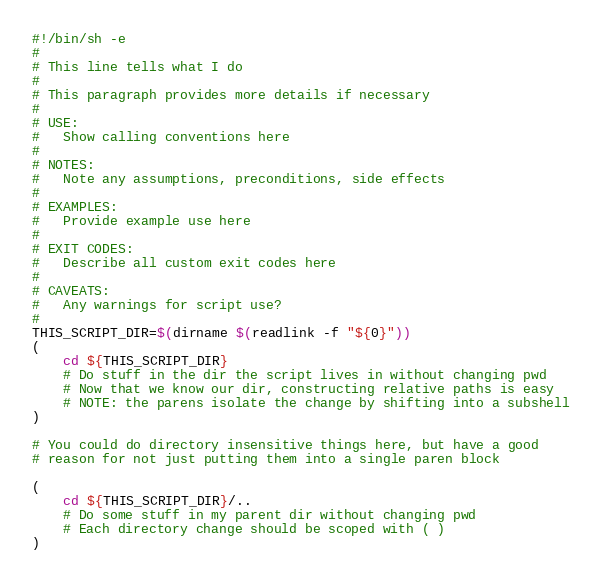Convert code to text. <code><loc_0><loc_0><loc_500><loc_500><_Bash_>#!/bin/sh -e
#
# This line tells what I do
#
# This paragraph provides more details if necessary
#
# USE:
#   Show calling conventions here
#
# NOTES:
#   Note any assumptions, preconditions, side effects
#
# EXAMPLES:
#   Provide example use here
#
# EXIT CODES:
#   Describe all custom exit codes here
#
# CAVEATS:
#   Any warnings for script use?
#
THIS_SCRIPT_DIR=$(dirname $(readlink -f "${0}"))
(
    cd ${THIS_SCRIPT_DIR}
    # Do stuff in the dir the script lives in without changing pwd
    # Now that we know our dir, constructing relative paths is easy
    # NOTE: the parens isolate the change by shifting into a subshell
)

# You could do directory insensitive things here, but have a good
# reason for not just putting them into a single paren block

(
    cd ${THIS_SCRIPT_DIR}/..
    # Do some stuff in my parent dir without changing pwd
    # Each directory change should be scoped with ( )
)
</code> 